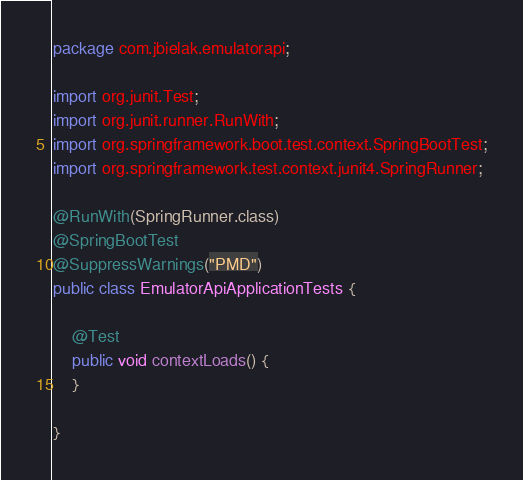Convert code to text. <code><loc_0><loc_0><loc_500><loc_500><_Java_>package com.jbielak.emulatorapi;

import org.junit.Test;
import org.junit.runner.RunWith;
import org.springframework.boot.test.context.SpringBootTest;
import org.springframework.test.context.junit4.SpringRunner;

@RunWith(SpringRunner.class)
@SpringBootTest
@SuppressWarnings("PMD")
public class EmulatorApiApplicationTests {

    @Test
    public void contextLoads() {
    }

}
</code> 